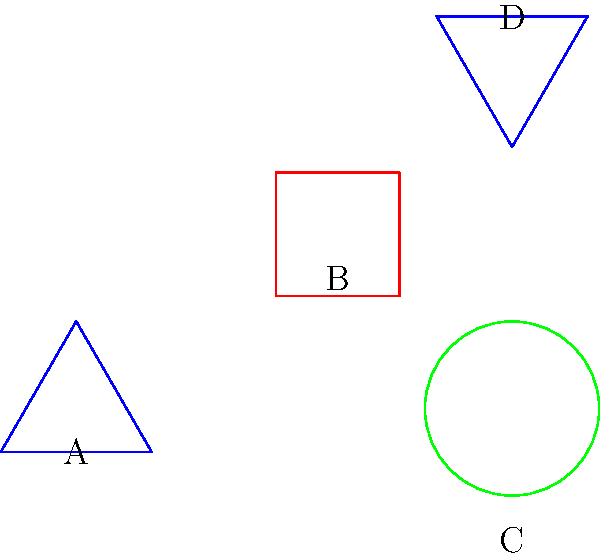In this stylized map of Jining City landmarks, which two shapes are congruent? To determine which shapes are congruent, we need to compare their properties:

1. Shape A: Blue triangle
2. Shape B: Red square
3. Shape C: Green circle
4. Shape D: Blue triangle

Step 1: Eliminate the non-triangular shapes
- Shape B (square) and Shape C (circle) are not congruent to any other shapes.

Step 2: Compare the remaining triangles
- Shape A and Shape D are both blue triangles.
- Shape D is rotated 180 degrees compared to Shape A.

Step 3: Check for congruence
- Congruent shapes have the same size and shape, regardless of their orientation.
- The rotation of Shape D does not affect its congruence to Shape A.

Therefore, Shape A and Shape D are congruent triangles.
Answer: A and D 